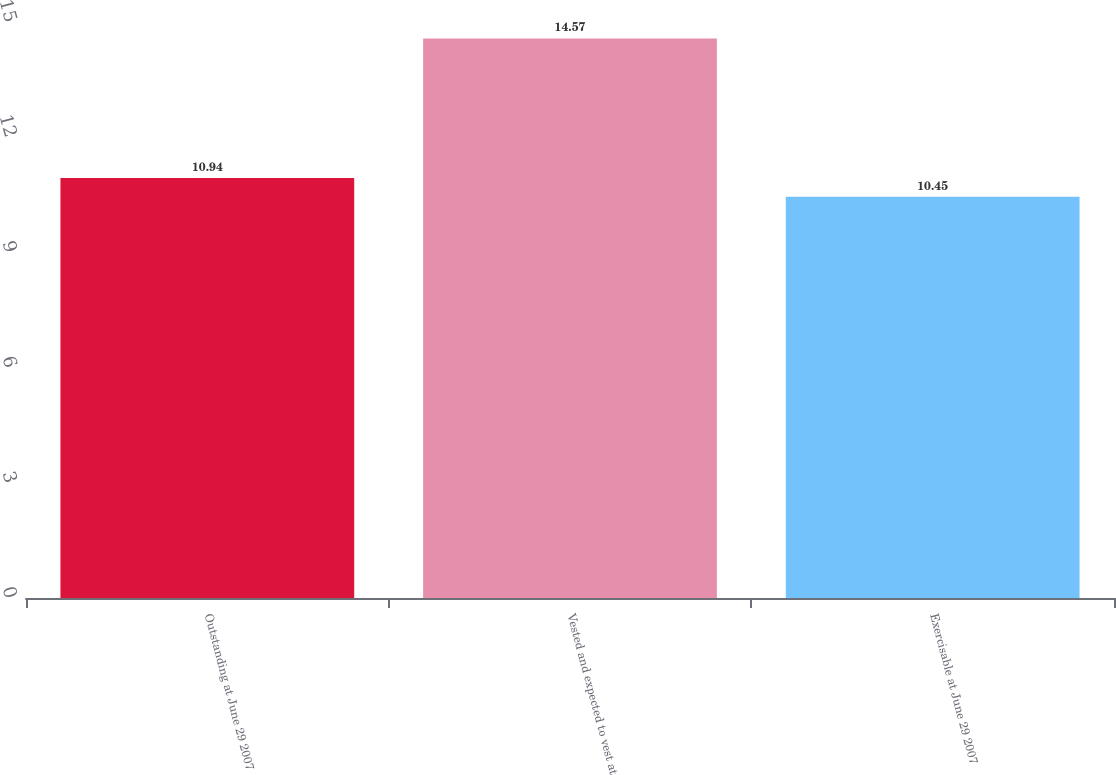Convert chart to OTSL. <chart><loc_0><loc_0><loc_500><loc_500><bar_chart><fcel>Outstanding at June 29 2007<fcel>Vested and expected to vest at<fcel>Exercisable at June 29 2007<nl><fcel>10.94<fcel>14.57<fcel>10.45<nl></chart> 